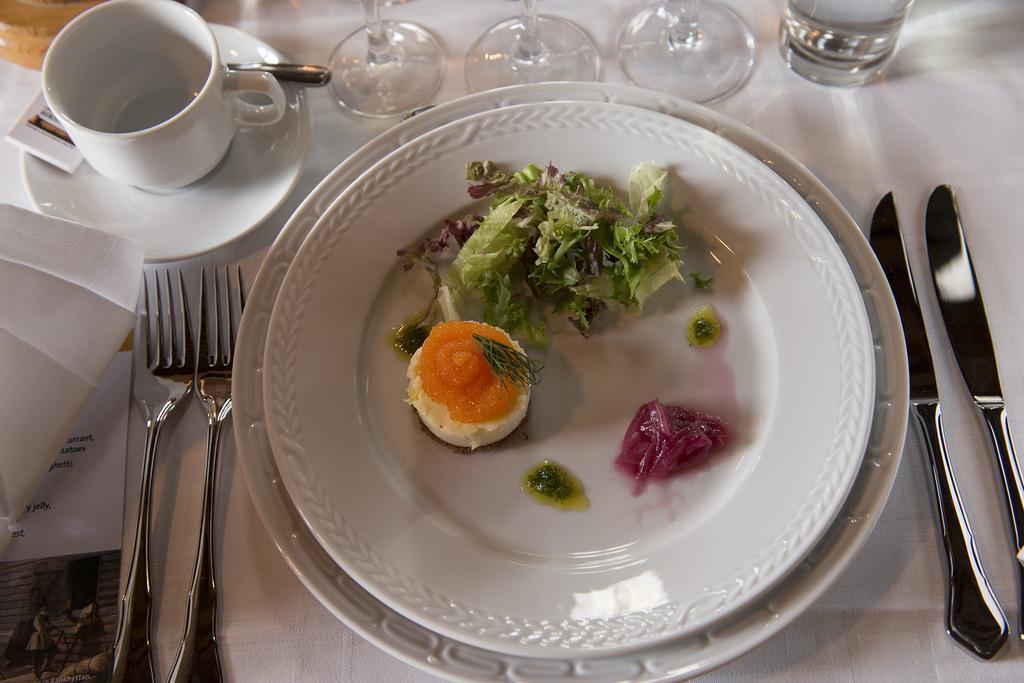Describe this image in one or two sentences. In the picture there are some food items served on a plate and beside the plate there are knives, forks, cup and saucer and few glasses. 